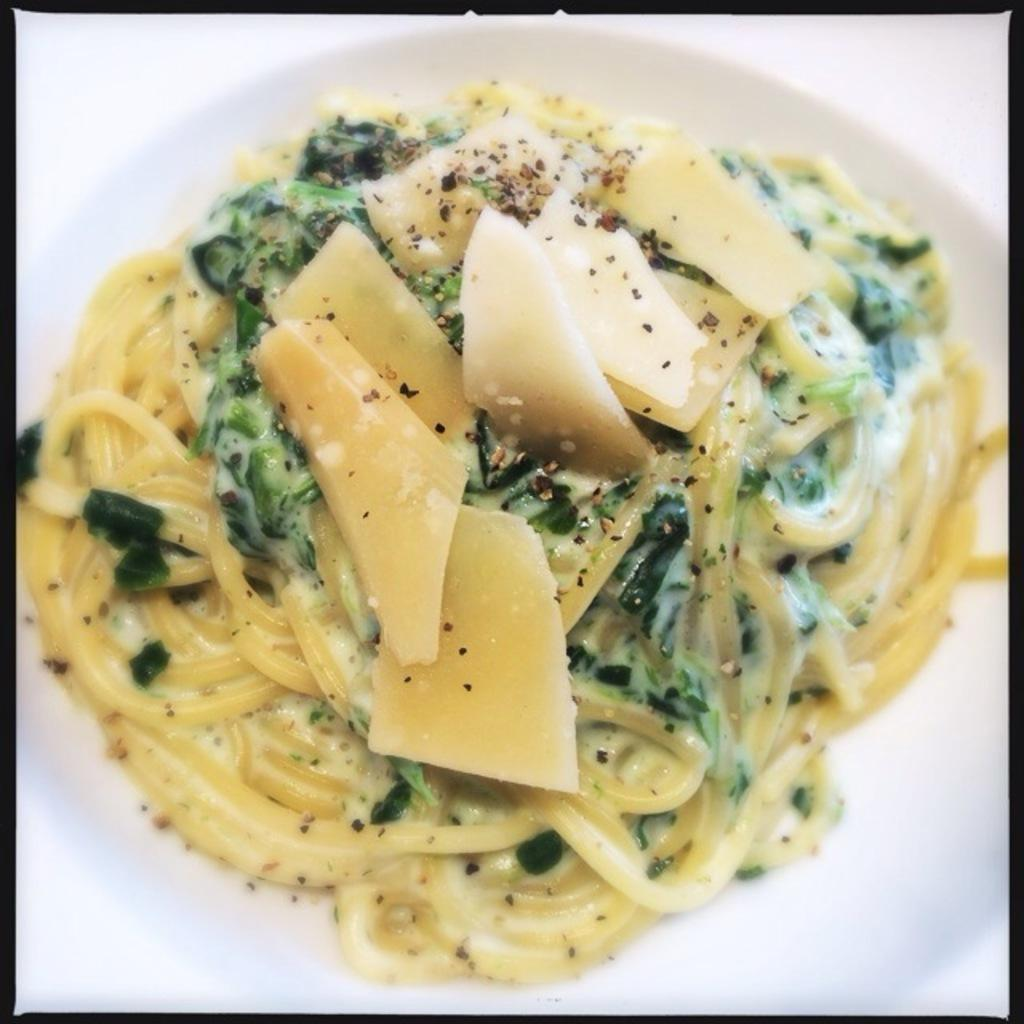What is the main subject of the image? The main subject of the image is a food item on a plate. Can you describe the food item on the plate? Unfortunately, the specific food item cannot be identified from the given facts. What is the plate placed on in the image? The facts provided do not specify what the plate is placed on. What type of toys can be seen interacting with the quince in the image? There is no quince or toys present in the image. 